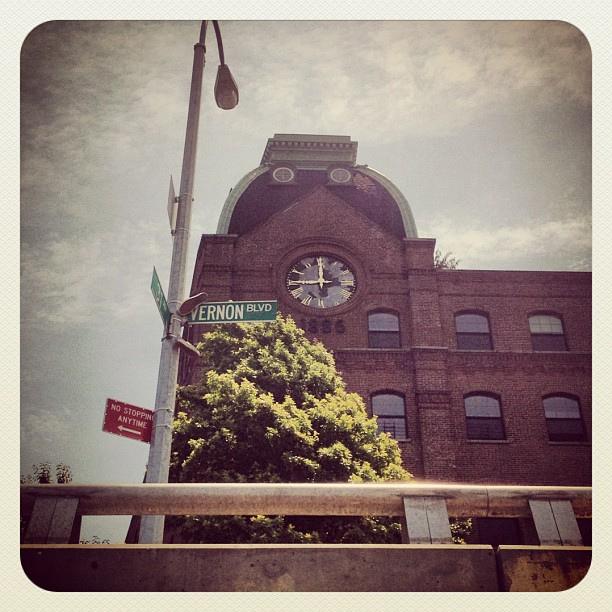What is Boulevard name?
Short answer required. Vernon. What does the clock say?
Give a very brief answer. 11:45. What is that clock tower located?
Write a very short answer. On vernon blvd. What time is shown on the clock?
Be succinct. 9:00. 